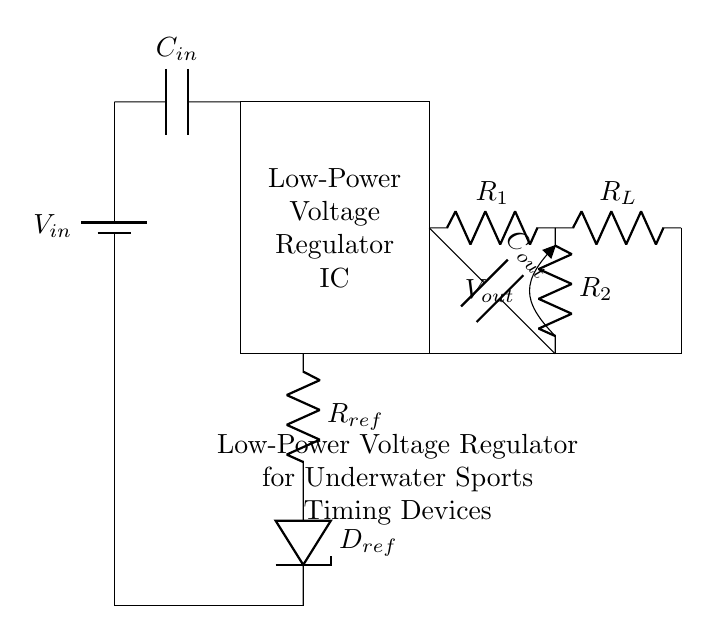What is the input voltage in this circuit? The input voltage is represented by V in the circuit diagram, which is denoted next to the battery symbol. It supplies power to the circuit.
Answer: V in What type of component is C in? C in is labeled as a capacitor in the circuit. Capacitors are energy storage components that smooth out voltage fluctuations.
Answer: Capacitor How many resistors are in the feedback network? The feedback network includes two resistors, R1 and R2, which are used to set the output voltage of the regulator.
Answer: Two What is the purpose of the output capacitor C out? The output capacitor C out is used to stabilize the output voltage and improve transient response of the voltage regulator under load conditions.
Answer: Stabilization Which component regulates the voltage in this circuit? The voltage regulator IC is the component that regulates and maintains a constant output voltage, despite variations in input voltage or load current.
Answer: Voltage Regulator IC How does the voltage regulator get its reference voltage? The reference voltage is provided by the resistor R ref connected to the Zener diode D ref, which sets a stable voltage level for the regulator to maintain.
Answer: R ref and D ref What is the load represented by in this circuit? The load is represented by the resistor R L connected to the output of the regulator, which represents the device being powered by the regulated voltage.
Answer: R L 